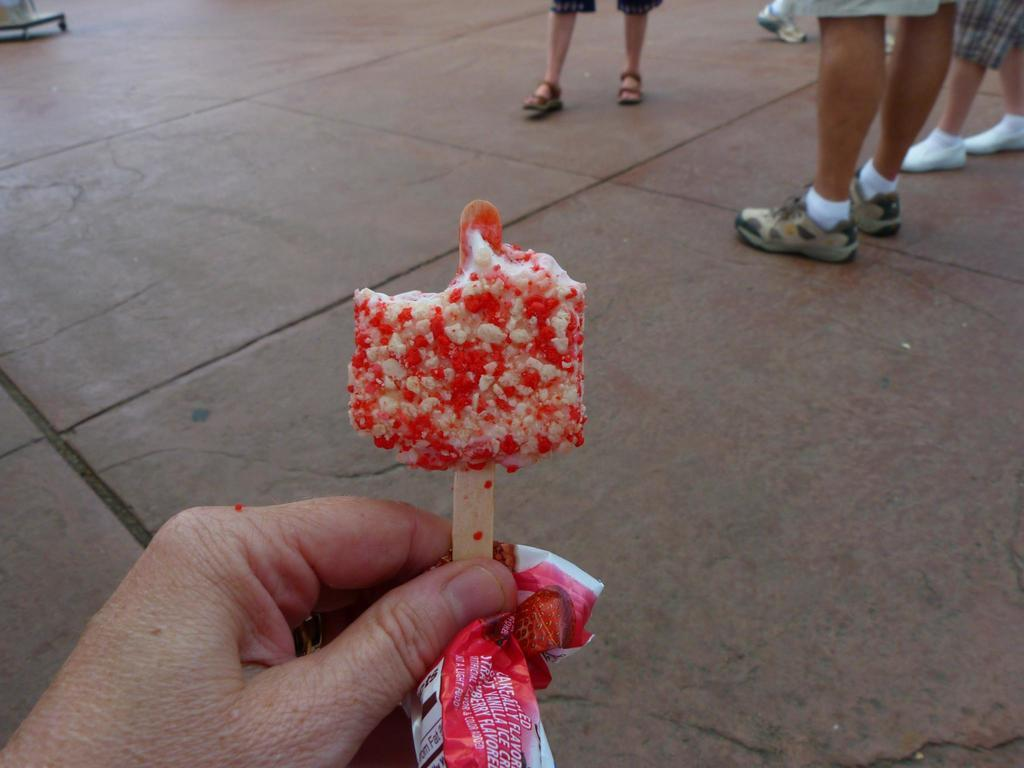What is the main subject of the image? The main subject of the image is an ice cream. What colors can be seen on the ice cream? The ice cream has red and white colors. Where is the ice cream located in the image? The ice cream is in the middle of the image. What can be seen in the background of the image? There are people standing in the background of the image. What is the people's position in relation to the floor? The people are standing on the floor. What type of crate is being used to store the ice cream in the image? There is no crate present in the image; the ice cream is not stored in a crate. How many friends are visible in the image? There is no mention of friends in the image; only people are mentioned in the background. 